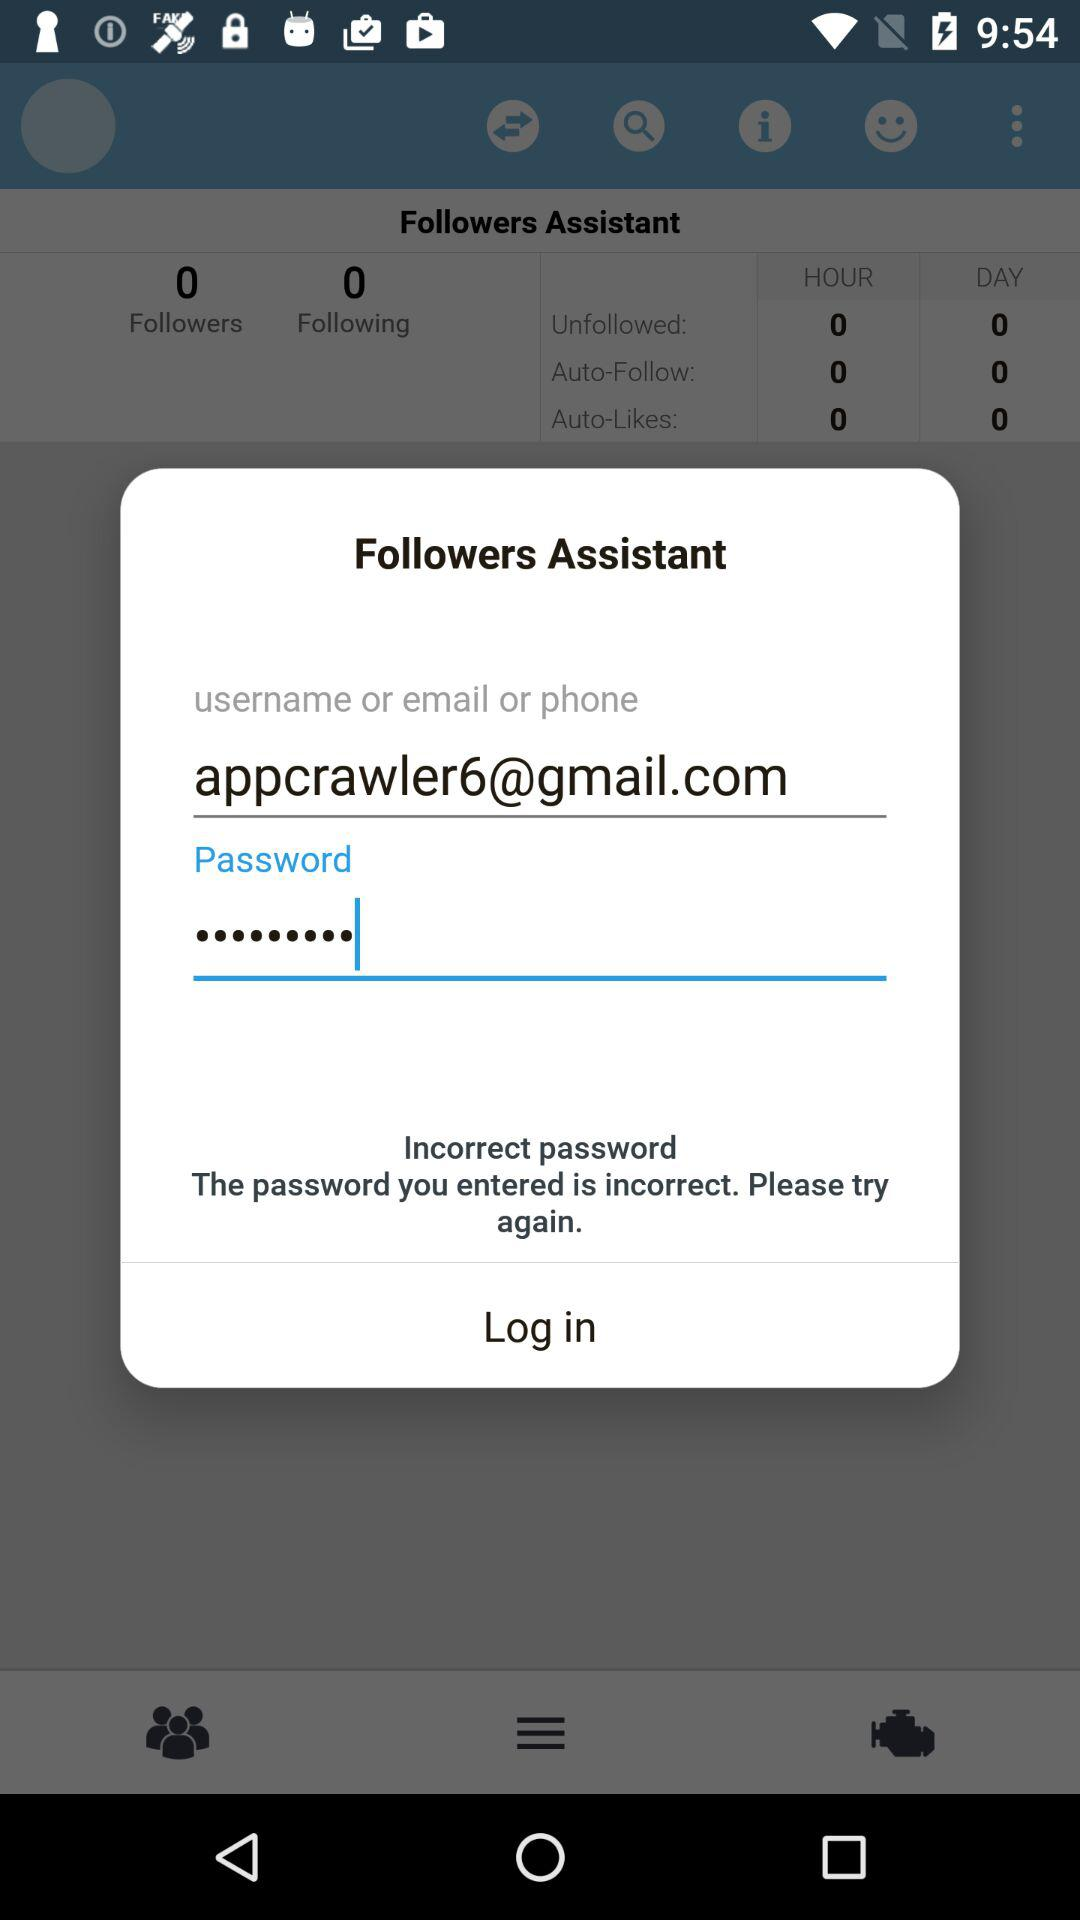What is the email address? The email address is appcrawler6@gmail.com. 